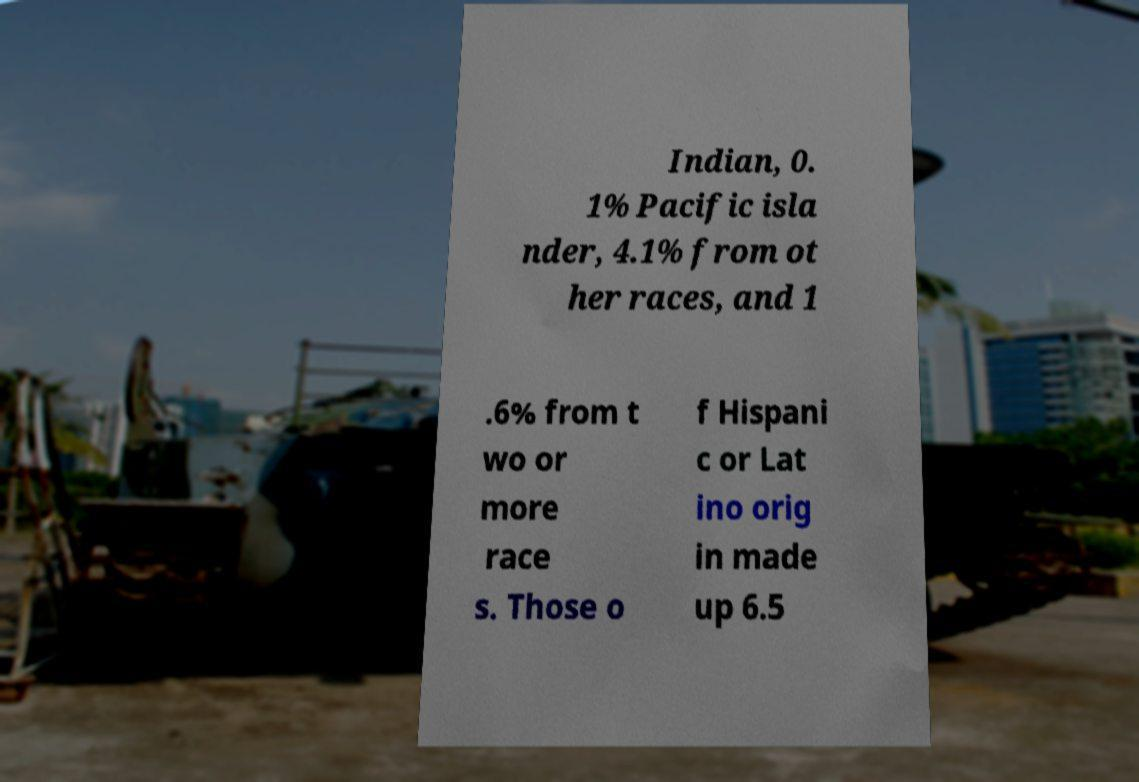Could you assist in decoding the text presented in this image and type it out clearly? Indian, 0. 1% Pacific isla nder, 4.1% from ot her races, and 1 .6% from t wo or more race s. Those o f Hispani c or Lat ino orig in made up 6.5 